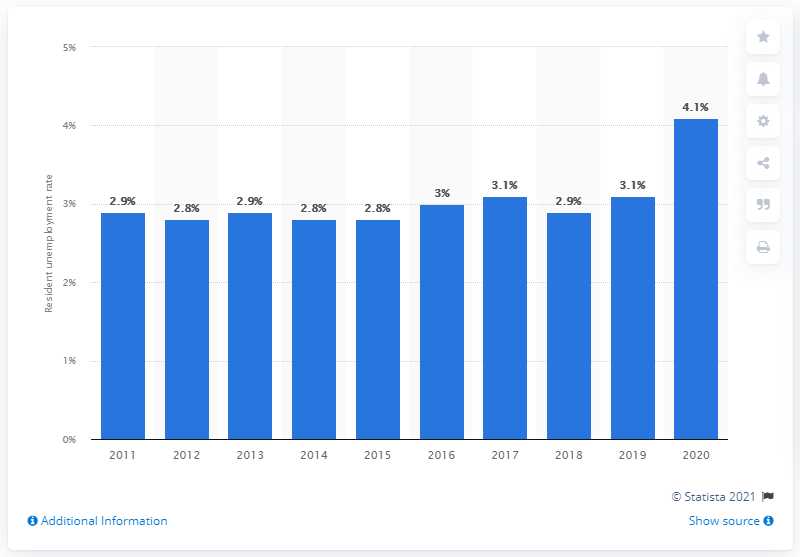Highlight a few significant elements in this photo. In 2020, the resident unemployment rate was 4.1%. 